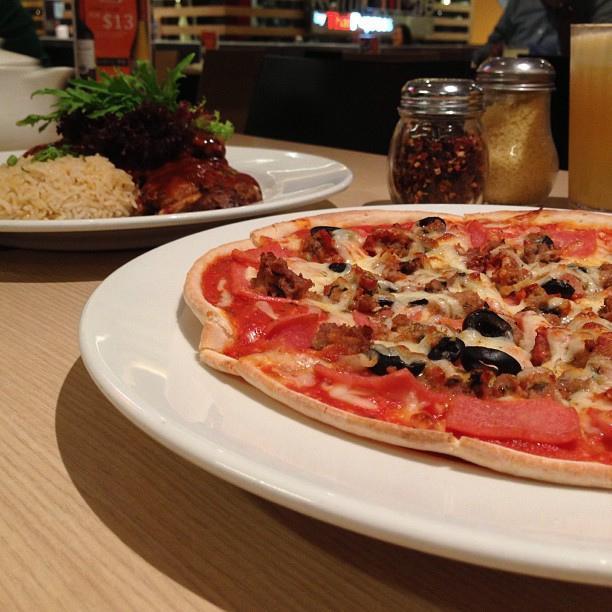How many dining tables can you see?
Give a very brief answer. 1. 